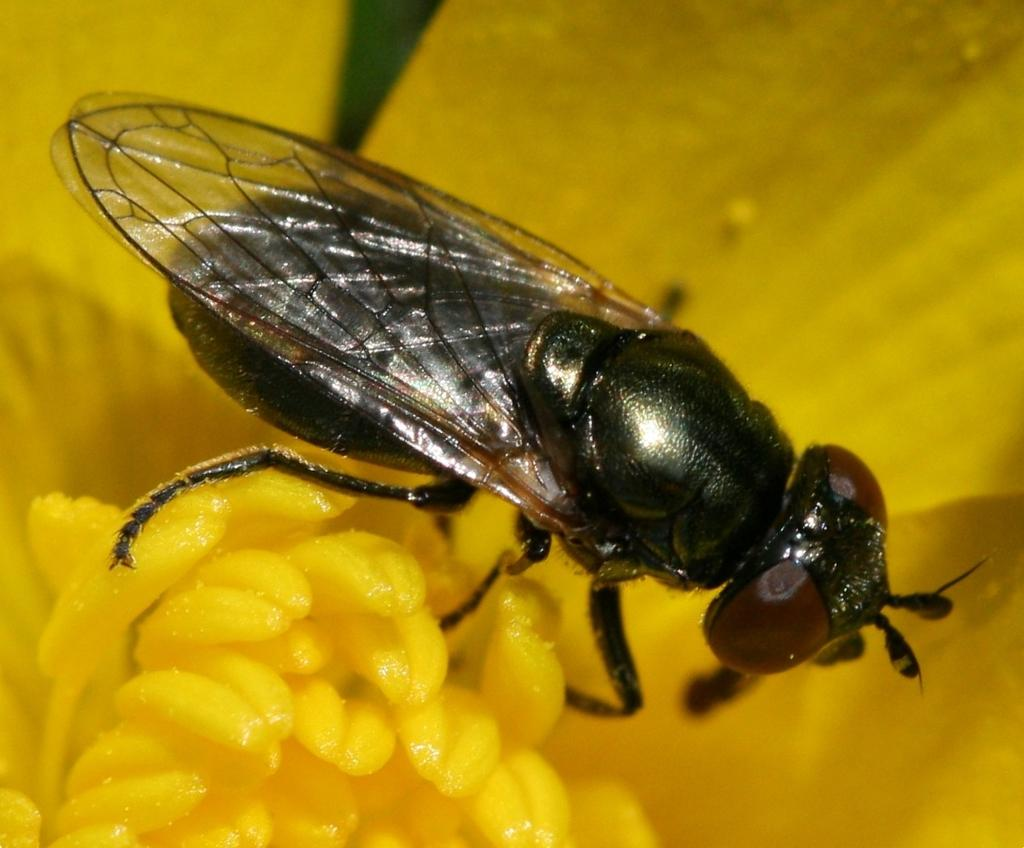What type of creature can be seen in the image? There is an insect in the image. What is the insect doing in the image? The insect is laying on a flower. What color is the insect in the image? The insect is black in color. What type of cheese is the fireman using to put out the fire in the image? There is no cheese, fireman, or fire present in the image. The image only features an insect laying on a flower. 